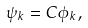<formula> <loc_0><loc_0><loc_500><loc_500>\psi _ { k } = C \phi _ { k } ,</formula> 